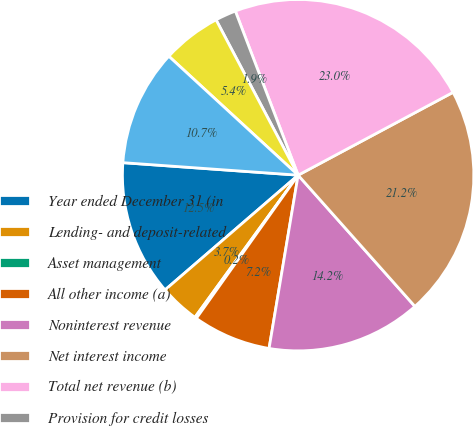Convert chart to OTSL. <chart><loc_0><loc_0><loc_500><loc_500><pie_chart><fcel>Year ended December 31 (in<fcel>Lending- and deposit-related<fcel>Asset management<fcel>All other income (a)<fcel>Noninterest revenue<fcel>Net interest income<fcel>Total net revenue (b)<fcel>Provision for credit losses<fcel>Compensation expense<fcel>Noncompensation expense<nl><fcel>12.46%<fcel>3.68%<fcel>0.16%<fcel>7.19%<fcel>14.22%<fcel>21.24%<fcel>23.0%<fcel>1.92%<fcel>5.43%<fcel>10.7%<nl></chart> 